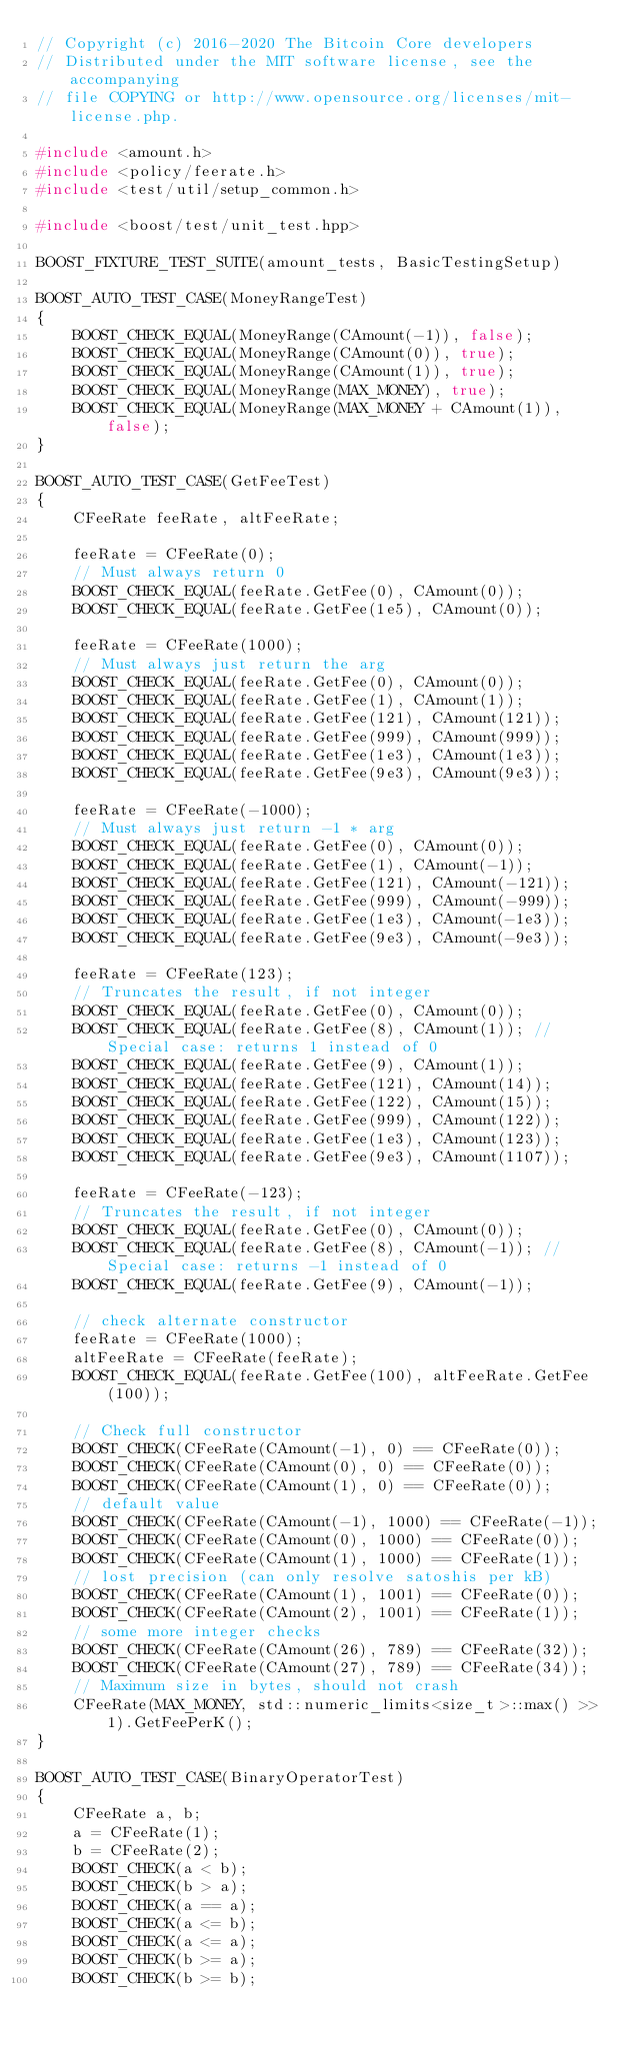Convert code to text. <code><loc_0><loc_0><loc_500><loc_500><_C++_>// Copyright (c) 2016-2020 The Bitcoin Core developers
// Distributed under the MIT software license, see the accompanying
// file COPYING or http://www.opensource.org/licenses/mit-license.php.

#include <amount.h>
#include <policy/feerate.h>
#include <test/util/setup_common.h>

#include <boost/test/unit_test.hpp>

BOOST_FIXTURE_TEST_SUITE(amount_tests, BasicTestingSetup)

BOOST_AUTO_TEST_CASE(MoneyRangeTest)
{
    BOOST_CHECK_EQUAL(MoneyRange(CAmount(-1)), false);
    BOOST_CHECK_EQUAL(MoneyRange(CAmount(0)), true);
    BOOST_CHECK_EQUAL(MoneyRange(CAmount(1)), true);
    BOOST_CHECK_EQUAL(MoneyRange(MAX_MONEY), true);
    BOOST_CHECK_EQUAL(MoneyRange(MAX_MONEY + CAmount(1)), false);
}

BOOST_AUTO_TEST_CASE(GetFeeTest)
{
    CFeeRate feeRate, altFeeRate;

    feeRate = CFeeRate(0);
    // Must always return 0
    BOOST_CHECK_EQUAL(feeRate.GetFee(0), CAmount(0));
    BOOST_CHECK_EQUAL(feeRate.GetFee(1e5), CAmount(0));

    feeRate = CFeeRate(1000);
    // Must always just return the arg
    BOOST_CHECK_EQUAL(feeRate.GetFee(0), CAmount(0));
    BOOST_CHECK_EQUAL(feeRate.GetFee(1), CAmount(1));
    BOOST_CHECK_EQUAL(feeRate.GetFee(121), CAmount(121));
    BOOST_CHECK_EQUAL(feeRate.GetFee(999), CAmount(999));
    BOOST_CHECK_EQUAL(feeRate.GetFee(1e3), CAmount(1e3));
    BOOST_CHECK_EQUAL(feeRate.GetFee(9e3), CAmount(9e3));

    feeRate = CFeeRate(-1000);
    // Must always just return -1 * arg
    BOOST_CHECK_EQUAL(feeRate.GetFee(0), CAmount(0));
    BOOST_CHECK_EQUAL(feeRate.GetFee(1), CAmount(-1));
    BOOST_CHECK_EQUAL(feeRate.GetFee(121), CAmount(-121));
    BOOST_CHECK_EQUAL(feeRate.GetFee(999), CAmount(-999));
    BOOST_CHECK_EQUAL(feeRate.GetFee(1e3), CAmount(-1e3));
    BOOST_CHECK_EQUAL(feeRate.GetFee(9e3), CAmount(-9e3));

    feeRate = CFeeRate(123);
    // Truncates the result, if not integer
    BOOST_CHECK_EQUAL(feeRate.GetFee(0), CAmount(0));
    BOOST_CHECK_EQUAL(feeRate.GetFee(8), CAmount(1)); // Special case: returns 1 instead of 0
    BOOST_CHECK_EQUAL(feeRate.GetFee(9), CAmount(1));
    BOOST_CHECK_EQUAL(feeRate.GetFee(121), CAmount(14));
    BOOST_CHECK_EQUAL(feeRate.GetFee(122), CAmount(15));
    BOOST_CHECK_EQUAL(feeRate.GetFee(999), CAmount(122));
    BOOST_CHECK_EQUAL(feeRate.GetFee(1e3), CAmount(123));
    BOOST_CHECK_EQUAL(feeRate.GetFee(9e3), CAmount(1107));

    feeRate = CFeeRate(-123);
    // Truncates the result, if not integer
    BOOST_CHECK_EQUAL(feeRate.GetFee(0), CAmount(0));
    BOOST_CHECK_EQUAL(feeRate.GetFee(8), CAmount(-1)); // Special case: returns -1 instead of 0
    BOOST_CHECK_EQUAL(feeRate.GetFee(9), CAmount(-1));

    // check alternate constructor
    feeRate = CFeeRate(1000);
    altFeeRate = CFeeRate(feeRate);
    BOOST_CHECK_EQUAL(feeRate.GetFee(100), altFeeRate.GetFee(100));

    // Check full constructor
    BOOST_CHECK(CFeeRate(CAmount(-1), 0) == CFeeRate(0));
    BOOST_CHECK(CFeeRate(CAmount(0), 0) == CFeeRate(0));
    BOOST_CHECK(CFeeRate(CAmount(1), 0) == CFeeRate(0));
    // default value
    BOOST_CHECK(CFeeRate(CAmount(-1), 1000) == CFeeRate(-1));
    BOOST_CHECK(CFeeRate(CAmount(0), 1000) == CFeeRate(0));
    BOOST_CHECK(CFeeRate(CAmount(1), 1000) == CFeeRate(1));
    // lost precision (can only resolve satoshis per kB)
    BOOST_CHECK(CFeeRate(CAmount(1), 1001) == CFeeRate(0));
    BOOST_CHECK(CFeeRate(CAmount(2), 1001) == CFeeRate(1));
    // some more integer checks
    BOOST_CHECK(CFeeRate(CAmount(26), 789) == CFeeRate(32));
    BOOST_CHECK(CFeeRate(CAmount(27), 789) == CFeeRate(34));
    // Maximum size in bytes, should not crash
    CFeeRate(MAX_MONEY, std::numeric_limits<size_t>::max() >> 1).GetFeePerK();
}

BOOST_AUTO_TEST_CASE(BinaryOperatorTest)
{
    CFeeRate a, b;
    a = CFeeRate(1);
    b = CFeeRate(2);
    BOOST_CHECK(a < b);
    BOOST_CHECK(b > a);
    BOOST_CHECK(a == a);
    BOOST_CHECK(a <= b);
    BOOST_CHECK(a <= a);
    BOOST_CHECK(b >= a);
    BOOST_CHECK(b >= b);</code> 